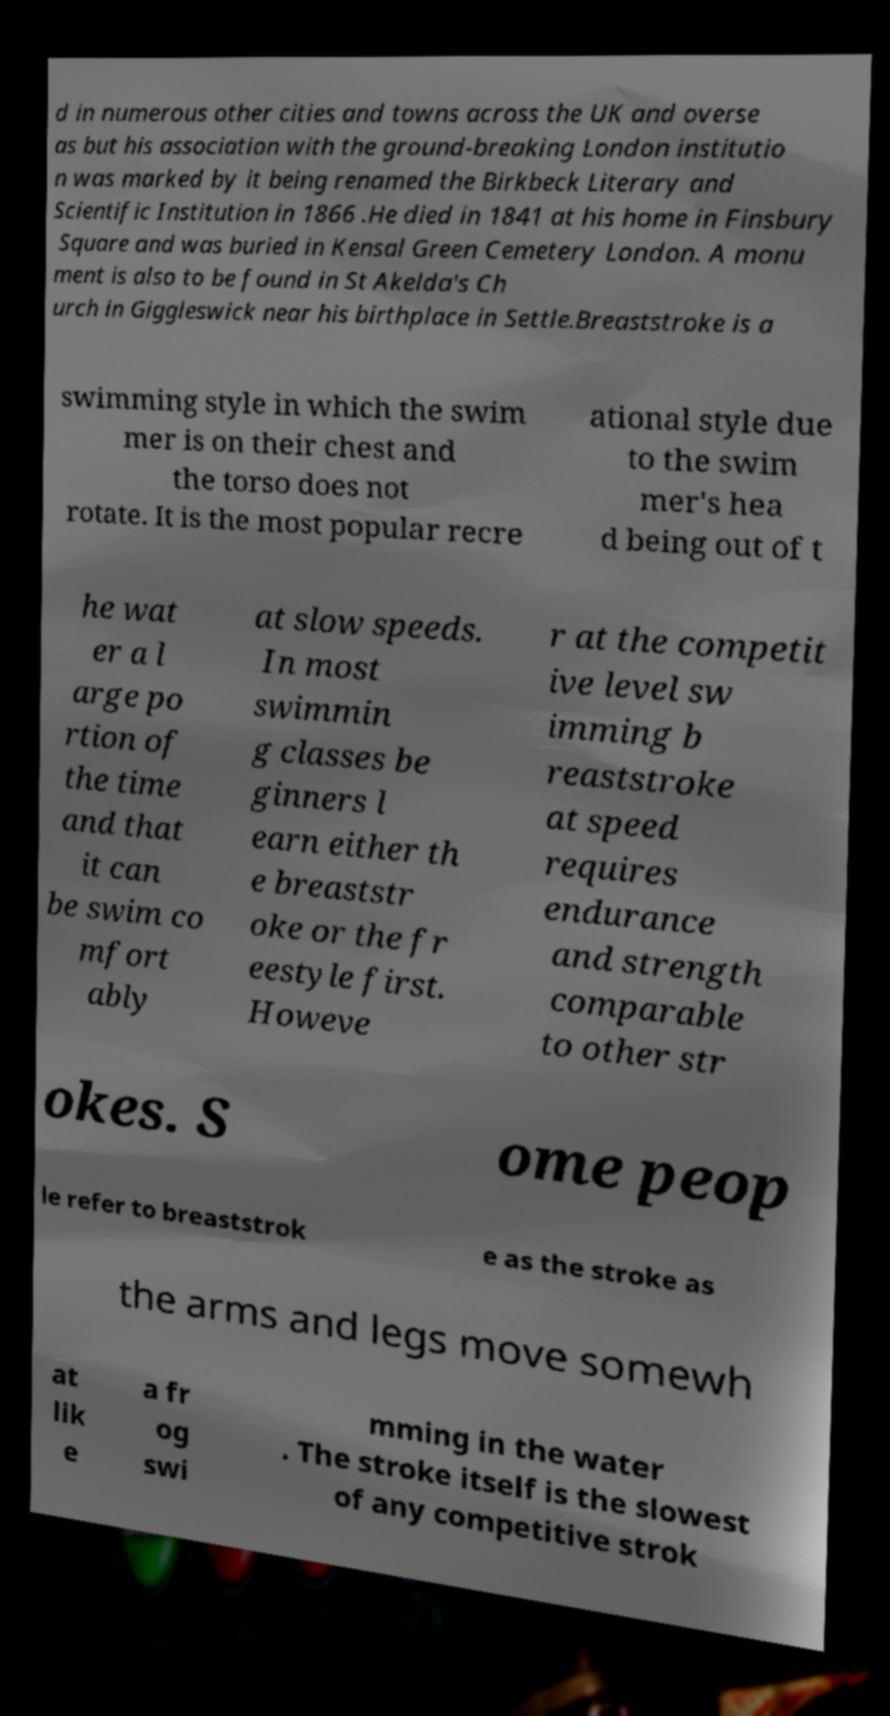Can you accurately transcribe the text from the provided image for me? d in numerous other cities and towns across the UK and overse as but his association with the ground-breaking London institutio n was marked by it being renamed the Birkbeck Literary and Scientific Institution in 1866 .He died in 1841 at his home in Finsbury Square and was buried in Kensal Green Cemetery London. A monu ment is also to be found in St Akelda's Ch urch in Giggleswick near his birthplace in Settle.Breaststroke is a swimming style in which the swim mer is on their chest and the torso does not rotate. It is the most popular recre ational style due to the swim mer's hea d being out of t he wat er a l arge po rtion of the time and that it can be swim co mfort ably at slow speeds. In most swimmin g classes be ginners l earn either th e breaststr oke or the fr eestyle first. Howeve r at the competit ive level sw imming b reaststroke at speed requires endurance and strength comparable to other str okes. S ome peop le refer to breaststrok e as the stroke as the arms and legs move somewh at lik e a fr og swi mming in the water . The stroke itself is the slowest of any competitive strok 